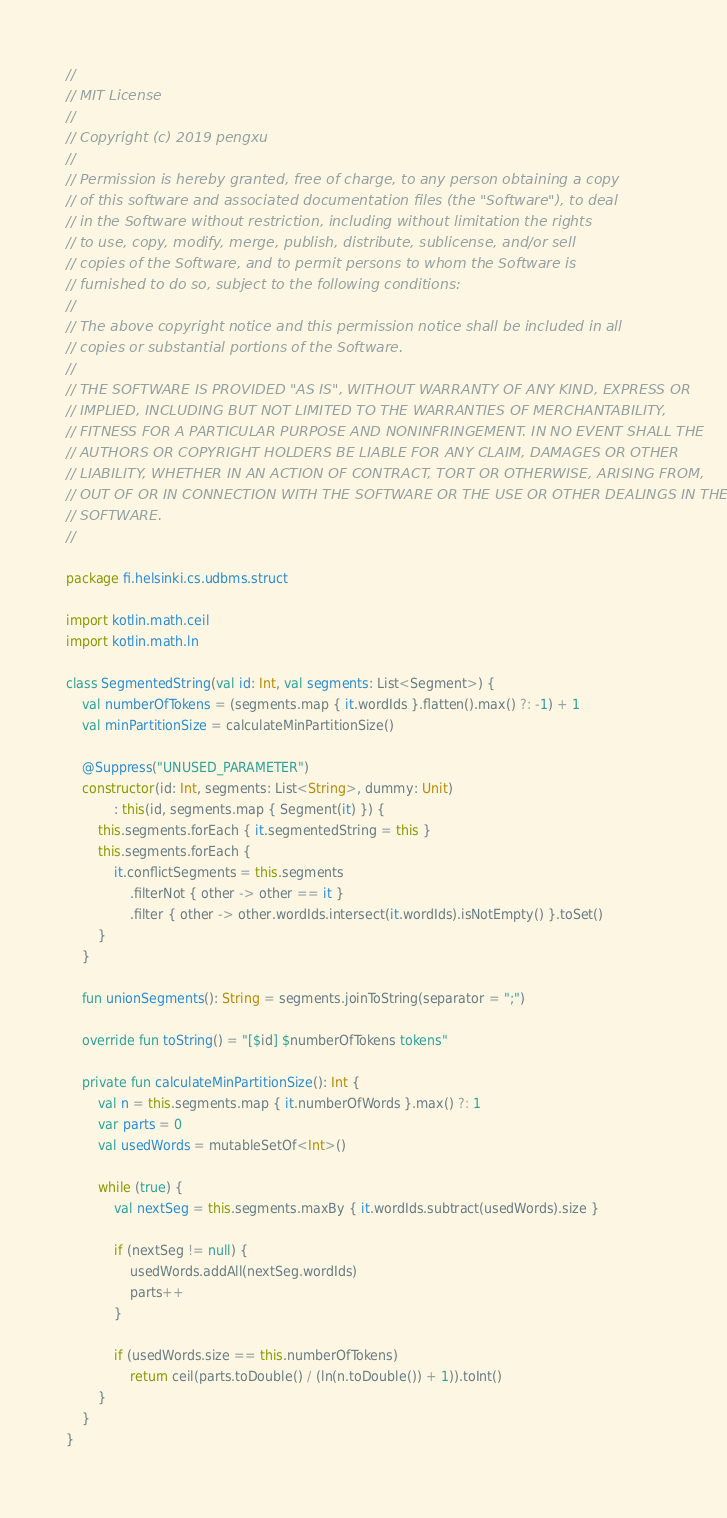<code> <loc_0><loc_0><loc_500><loc_500><_Kotlin_>// 
// MIT License
// 
// Copyright (c) 2019 pengxu
// 
// Permission is hereby granted, free of charge, to any person obtaining a copy
// of this software and associated documentation files (the "Software"), to deal
// in the Software without restriction, including without limitation the rights
// to use, copy, modify, merge, publish, distribute, sublicense, and/or sell
// copies of the Software, and to permit persons to whom the Software is
// furnished to do so, subject to the following conditions:
// 
// The above copyright notice and this permission notice shall be included in all
// copies or substantial portions of the Software.
// 
// THE SOFTWARE IS PROVIDED "AS IS", WITHOUT WARRANTY OF ANY KIND, EXPRESS OR
// IMPLIED, INCLUDING BUT NOT LIMITED TO THE WARRANTIES OF MERCHANTABILITY,
// FITNESS FOR A PARTICULAR PURPOSE AND NONINFRINGEMENT. IN NO EVENT SHALL THE
// AUTHORS OR COPYRIGHT HOLDERS BE LIABLE FOR ANY CLAIM, DAMAGES OR OTHER
// LIABILITY, WHETHER IN AN ACTION OF CONTRACT, TORT OR OTHERWISE, ARISING FROM,
// OUT OF OR IN CONNECTION WITH THE SOFTWARE OR THE USE OR OTHER DEALINGS IN THE
// SOFTWARE.
// 

package fi.helsinki.cs.udbms.struct

import kotlin.math.ceil
import kotlin.math.ln

class SegmentedString(val id: Int, val segments: List<Segment>) {
    val numberOfTokens = (segments.map { it.wordIds }.flatten().max() ?: -1) + 1
    val minPartitionSize = calculateMinPartitionSize()

    @Suppress("UNUSED_PARAMETER")
    constructor(id: Int, segments: List<String>, dummy: Unit)
            : this(id, segments.map { Segment(it) }) {
        this.segments.forEach { it.segmentedString = this }
        this.segments.forEach {
            it.conflictSegments = this.segments
                .filterNot { other -> other == it }
                .filter { other -> other.wordIds.intersect(it.wordIds).isNotEmpty() }.toSet()
        }
    }

    fun unionSegments(): String = segments.joinToString(separator = ";")

    override fun toString() = "[$id] $numberOfTokens tokens"

    private fun calculateMinPartitionSize(): Int {
        val n = this.segments.map { it.numberOfWords }.max() ?: 1
        var parts = 0
        val usedWords = mutableSetOf<Int>()

        while (true) {
            val nextSeg = this.segments.maxBy { it.wordIds.subtract(usedWords).size }

            if (nextSeg != null) {
                usedWords.addAll(nextSeg.wordIds)
                parts++
            }

            if (usedWords.size == this.numberOfTokens)
                return ceil(parts.toDouble() / (ln(n.toDouble()) + 1)).toInt()
        }
    }
}</code> 